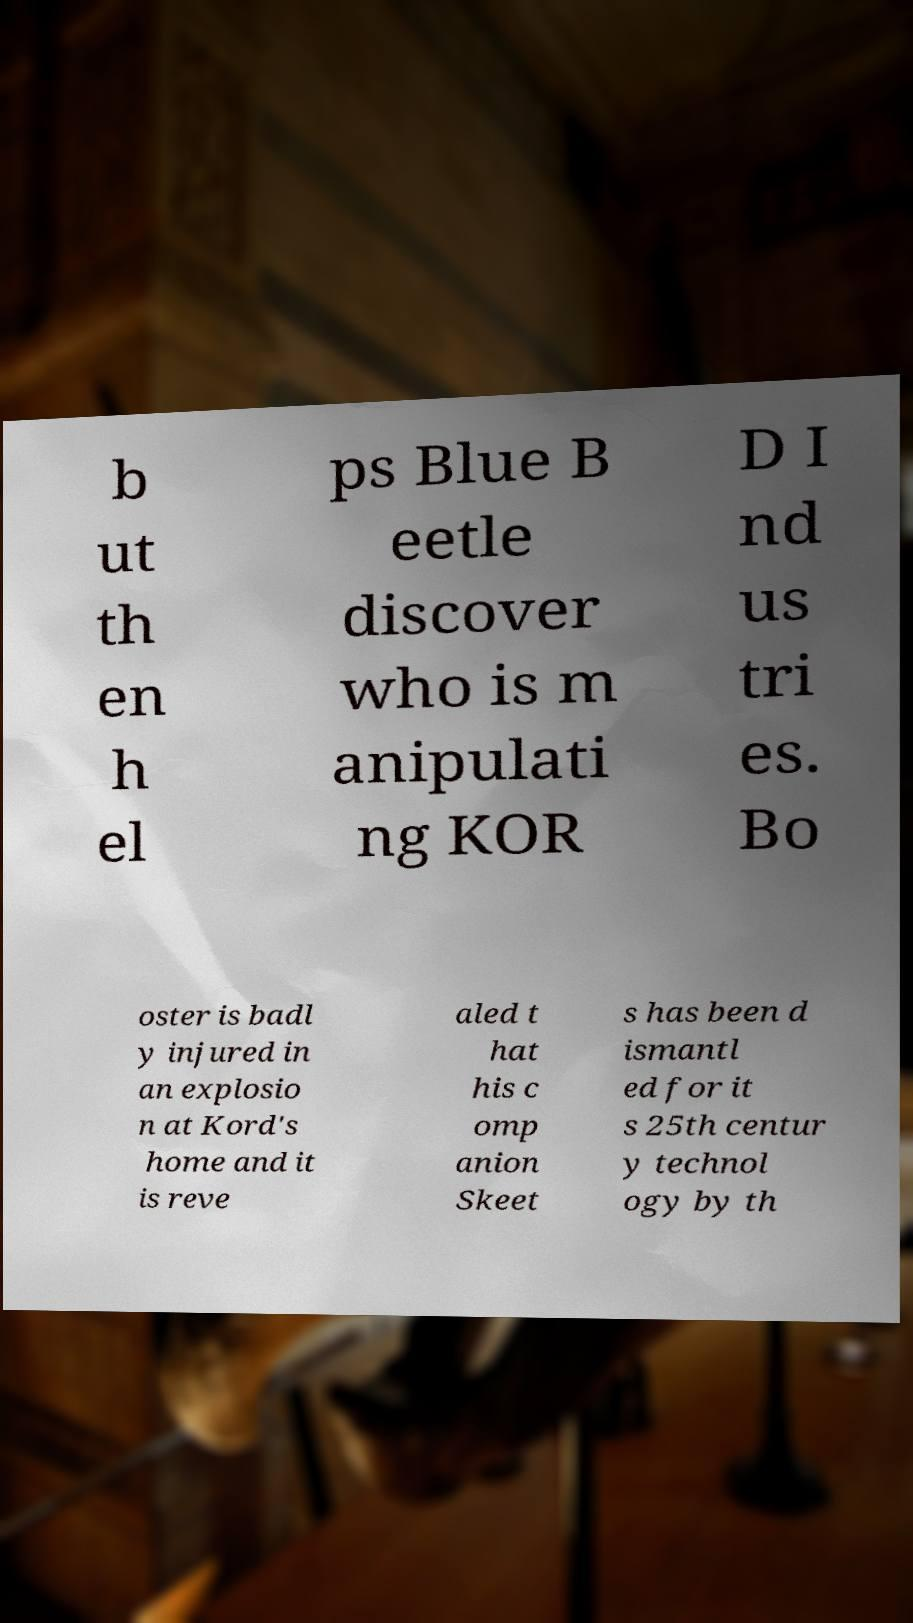Can you accurately transcribe the text from the provided image for me? b ut th en h el ps Blue B eetle discover who is m anipulati ng KOR D I nd us tri es. Bo oster is badl y injured in an explosio n at Kord's home and it is reve aled t hat his c omp anion Skeet s has been d ismantl ed for it s 25th centur y technol ogy by th 